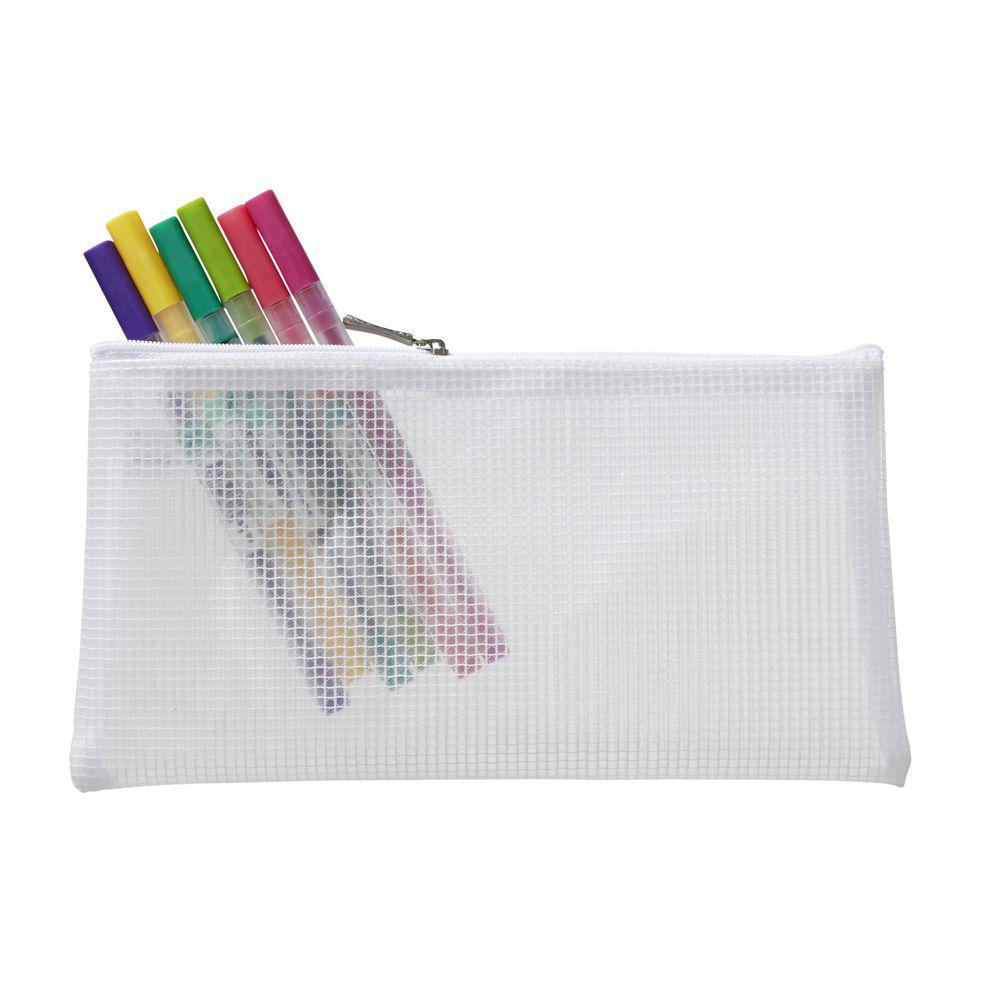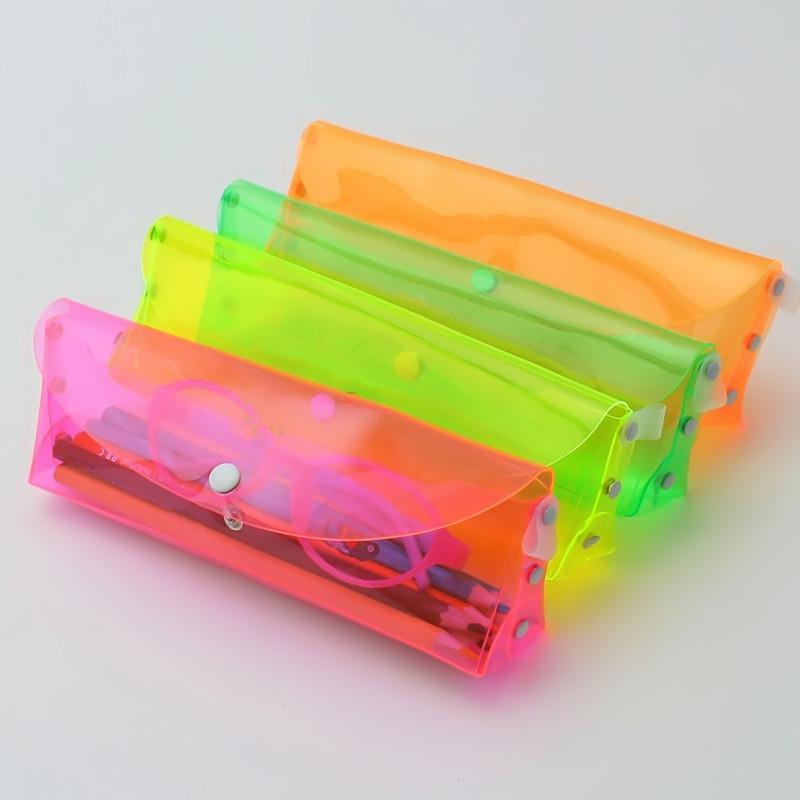The first image is the image on the left, the second image is the image on the right. Considering the images on both sides, is "There are exactly two pouches in total." valid? Answer yes or no. No. The first image is the image on the left, the second image is the image on the right. Examine the images to the left and right. Is the description "There are exactly two translucent pencil pouches." accurate? Answer yes or no. No. 